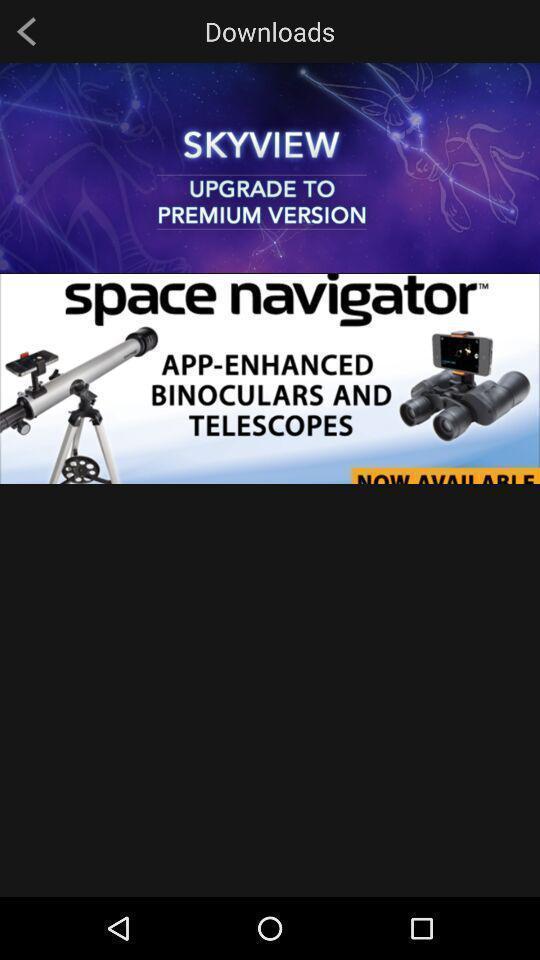Give me a narrative description of this picture. Page displaying the downloads. 